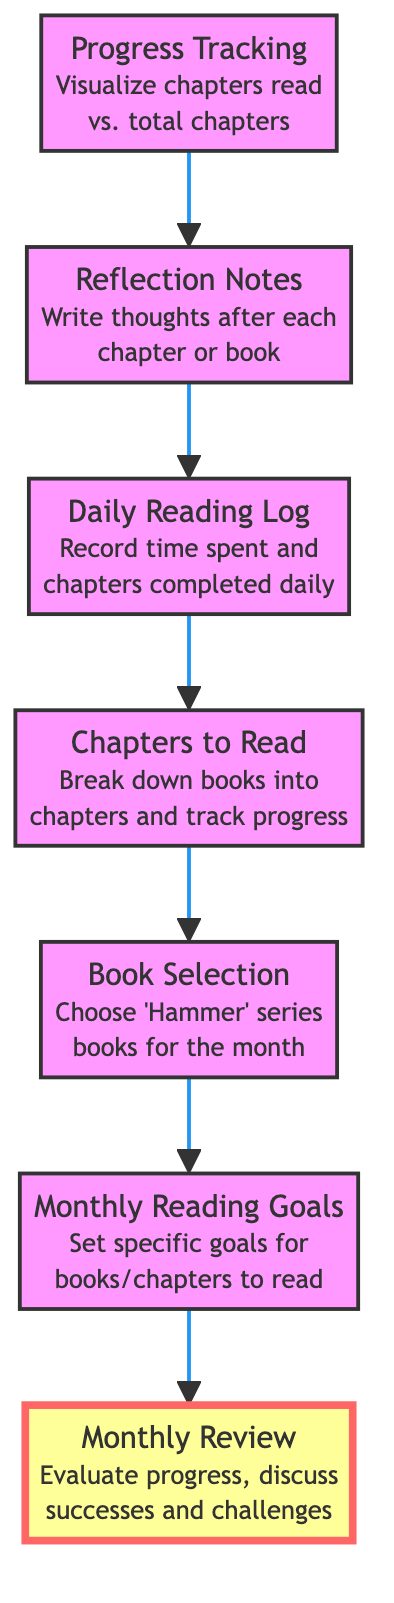what is the first node in the diagram? The first node refers to the starting point of the flowchart, which is labeled as "Monthly Reading Goals". It's the top element that connects directly to other nodes below it.
Answer: Monthly Reading Goals how many nodes are in the flowchart? To determine the number of nodes, we count all the labeled elements in the diagram, which totals to seven distinct nodes.
Answer: 7 what does the "Reflection Notes" node connect to? The "Reflection Notes" node connects to the "Daily Reading Log" node, indicating that reflection follows the logging of daily reading sessions.
Answer: Daily Reading Log which node does not connect to any other nodes? The node "Monthly Review" is the final node in the flowchart, indicating that it does not lead to any other nodes or processes, concluding the monthly progress plan.
Answer: Monthly Review what is the relationship between "Daily Reading Log" and "Progress Tracking"? The "Daily Reading Log" serves as a prerequisite for "Progress Tracking", meaning that the daily records feed into the tracking of overall reading progress.
Answer: Daily Reading Log to Progress Tracking how many connections are there emanating from the "Chapters to Read" node? The "Chapters to Read" node has one connection that leads to the "Daily Reading Log" node, indicating a direct flow from chapter breakdown to daily tracking.
Answer: 1 which node represents the visualization of reading progress? The node labeled "Progress Tracking" is dedicated to visualizing the reading progress, including chapters that have been read in comparison to total chapters available.
Answer: Progress Tracking what is the purpose of the "Monthly Review" node? The "Monthly Review" node is intended to evaluate the overall progress of the month, identifying successes and challenges faced, making it a reflective summary of the entire reading process.
Answer: Evaluate progress which node comes directly after "Chapters to Read"? The node that comes directly after "Chapters to Read" is "Daily Reading Log", indicating that tracking daily progress follows the breakdown of chapters.
Answer: Daily Reading Log 